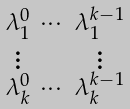Convert formula to latex. <formula><loc_0><loc_0><loc_500><loc_500>\begin{smallmatrix} \lambda _ { 1 } ^ { 0 } & \cdots & \lambda _ { 1 } ^ { k - 1 } \\ \vdots & & \vdots \\ \lambda _ { k } ^ { 0 } & \cdots & \lambda _ { k } ^ { k - 1 } \end{smallmatrix}</formula> 